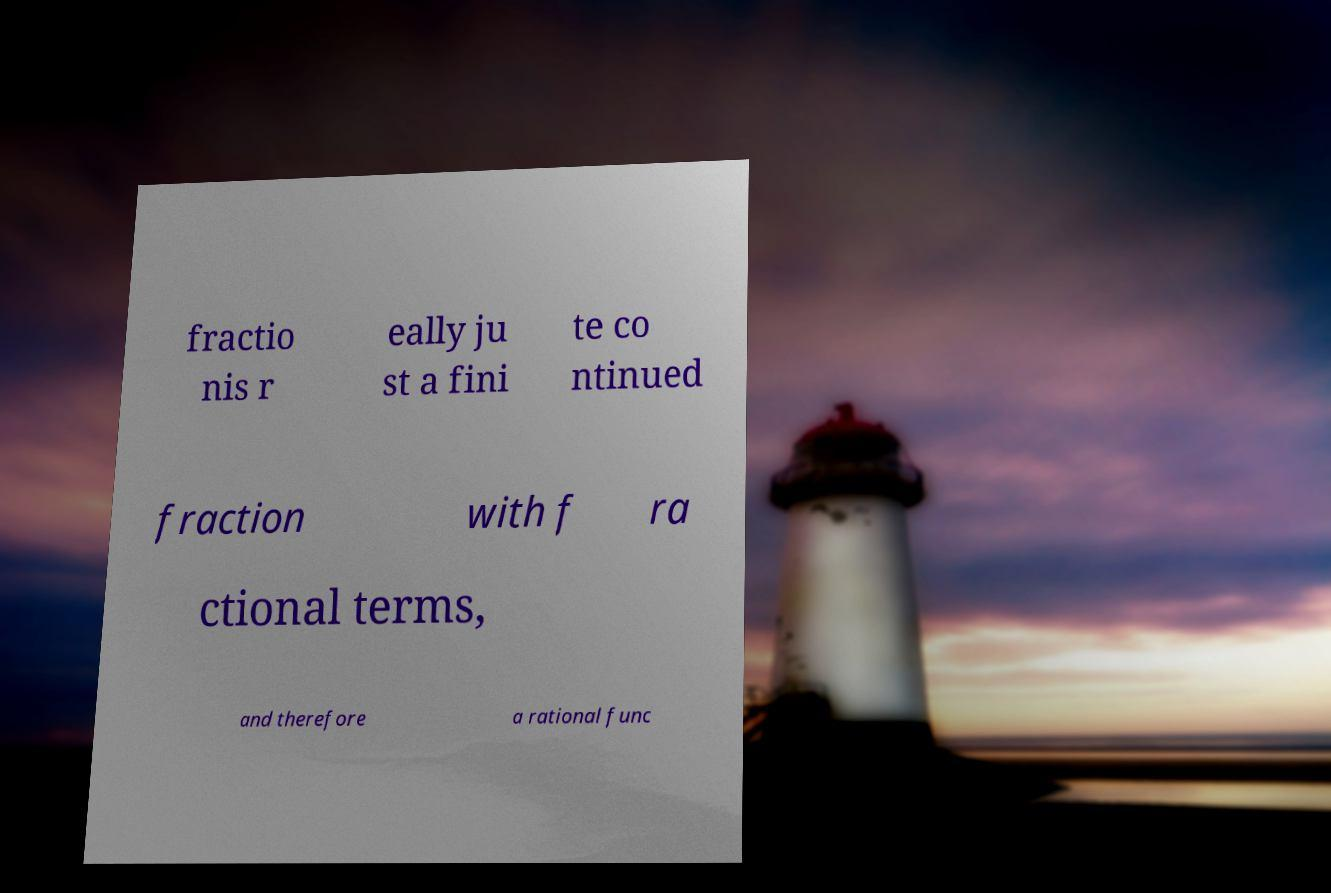Please identify and transcribe the text found in this image. fractio nis r eally ju st a fini te co ntinued fraction with f ra ctional terms, and therefore a rational func 